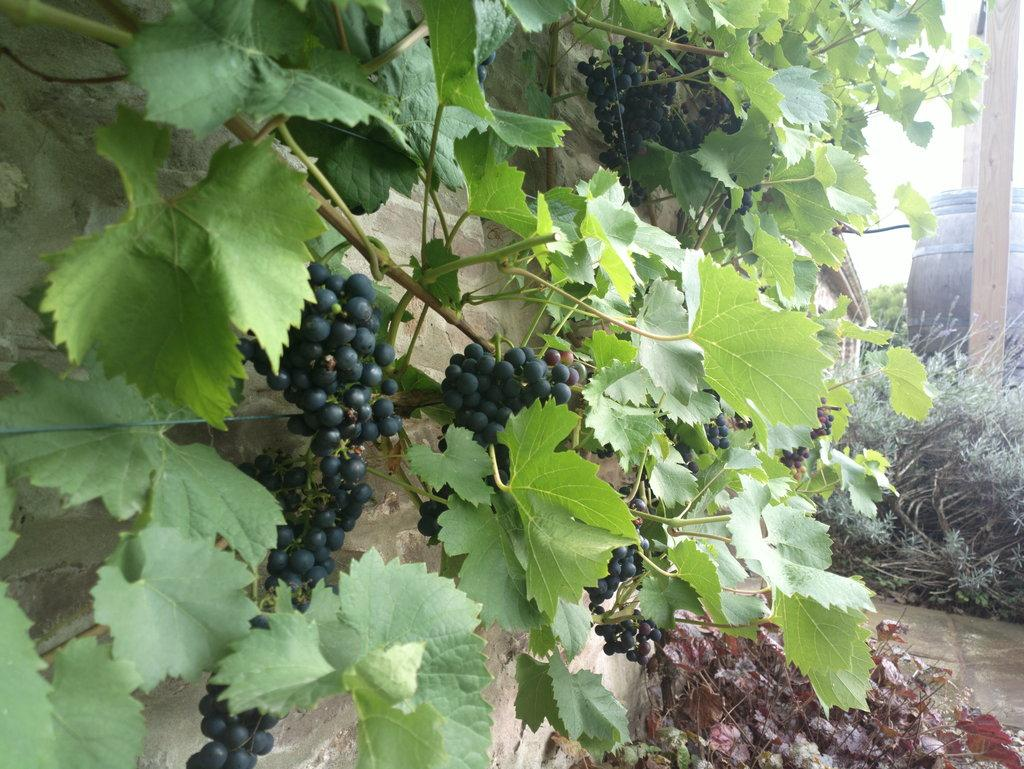What type of plant is the main subject of the image? There is a grapevine in the image. What other plants can be seen in the image? There are plants in front of the grapevine. What is the condition of the leaves in the image? Dry leaves are present in the image. What type of container is visible in the image? There is a barrel in the image. What type of trouble is the grapevine causing in the image? There is no indication of trouble or any problematic situation involving the grapevine in the image. 